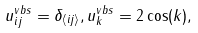<formula> <loc_0><loc_0><loc_500><loc_500>u ^ { v b s } _ { i j } = \delta _ { \langle i j \rangle } , u ^ { v b s } _ { k } = 2 \cos ( k ) ,</formula> 